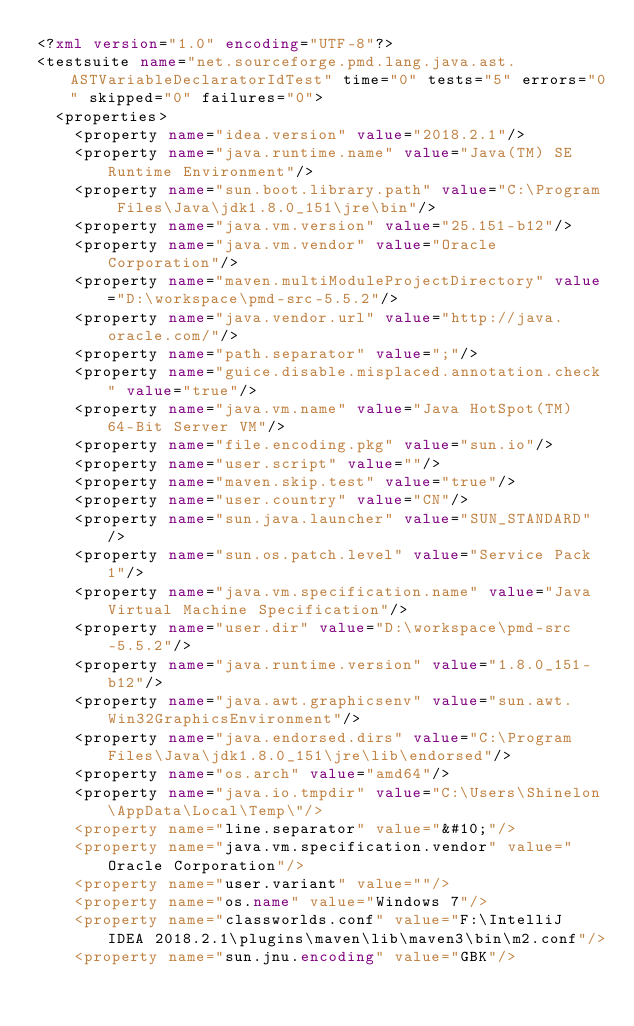<code> <loc_0><loc_0><loc_500><loc_500><_XML_><?xml version="1.0" encoding="UTF-8"?>
<testsuite name="net.sourceforge.pmd.lang.java.ast.ASTVariableDeclaratorIdTest" time="0" tests="5" errors="0" skipped="0" failures="0">
  <properties>
    <property name="idea.version" value="2018.2.1"/>
    <property name="java.runtime.name" value="Java(TM) SE Runtime Environment"/>
    <property name="sun.boot.library.path" value="C:\Program Files\Java\jdk1.8.0_151\jre\bin"/>
    <property name="java.vm.version" value="25.151-b12"/>
    <property name="java.vm.vendor" value="Oracle Corporation"/>
    <property name="maven.multiModuleProjectDirectory" value="D:\workspace\pmd-src-5.5.2"/>
    <property name="java.vendor.url" value="http://java.oracle.com/"/>
    <property name="path.separator" value=";"/>
    <property name="guice.disable.misplaced.annotation.check" value="true"/>
    <property name="java.vm.name" value="Java HotSpot(TM) 64-Bit Server VM"/>
    <property name="file.encoding.pkg" value="sun.io"/>
    <property name="user.script" value=""/>
    <property name="maven.skip.test" value="true"/>
    <property name="user.country" value="CN"/>
    <property name="sun.java.launcher" value="SUN_STANDARD"/>
    <property name="sun.os.patch.level" value="Service Pack 1"/>
    <property name="java.vm.specification.name" value="Java Virtual Machine Specification"/>
    <property name="user.dir" value="D:\workspace\pmd-src-5.5.2"/>
    <property name="java.runtime.version" value="1.8.0_151-b12"/>
    <property name="java.awt.graphicsenv" value="sun.awt.Win32GraphicsEnvironment"/>
    <property name="java.endorsed.dirs" value="C:\Program Files\Java\jdk1.8.0_151\jre\lib\endorsed"/>
    <property name="os.arch" value="amd64"/>
    <property name="java.io.tmpdir" value="C:\Users\Shinelon\AppData\Local\Temp\"/>
    <property name="line.separator" value="&#10;"/>
    <property name="java.vm.specification.vendor" value="Oracle Corporation"/>
    <property name="user.variant" value=""/>
    <property name="os.name" value="Windows 7"/>
    <property name="classworlds.conf" value="F:\IntelliJ IDEA 2018.2.1\plugins\maven\lib\maven3\bin\m2.conf"/>
    <property name="sun.jnu.encoding" value="GBK"/></code> 